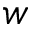Convert formula to latex. <formula><loc_0><loc_0><loc_500><loc_500>w</formula> 